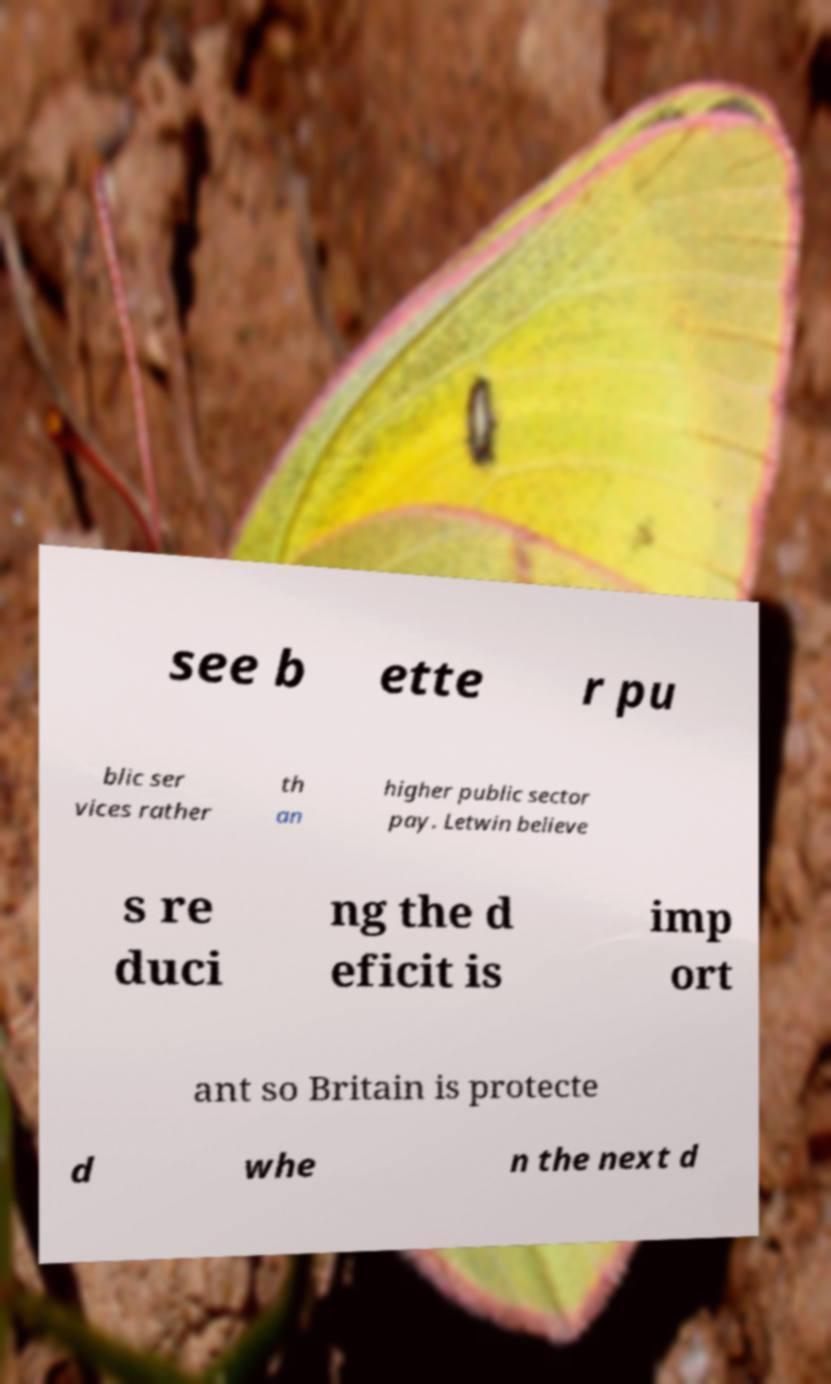What messages or text are displayed in this image? I need them in a readable, typed format. see b ette r pu blic ser vices rather th an higher public sector pay. Letwin believe s re duci ng the d eficit is imp ort ant so Britain is protecte d whe n the next d 